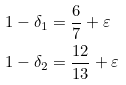Convert formula to latex. <formula><loc_0><loc_0><loc_500><loc_500>1 - \delta _ { 1 } & = \frac { 6 } { 7 } + \varepsilon \\ 1 - \delta _ { 2 } & = \frac { 1 2 } { 1 3 } + \varepsilon</formula> 